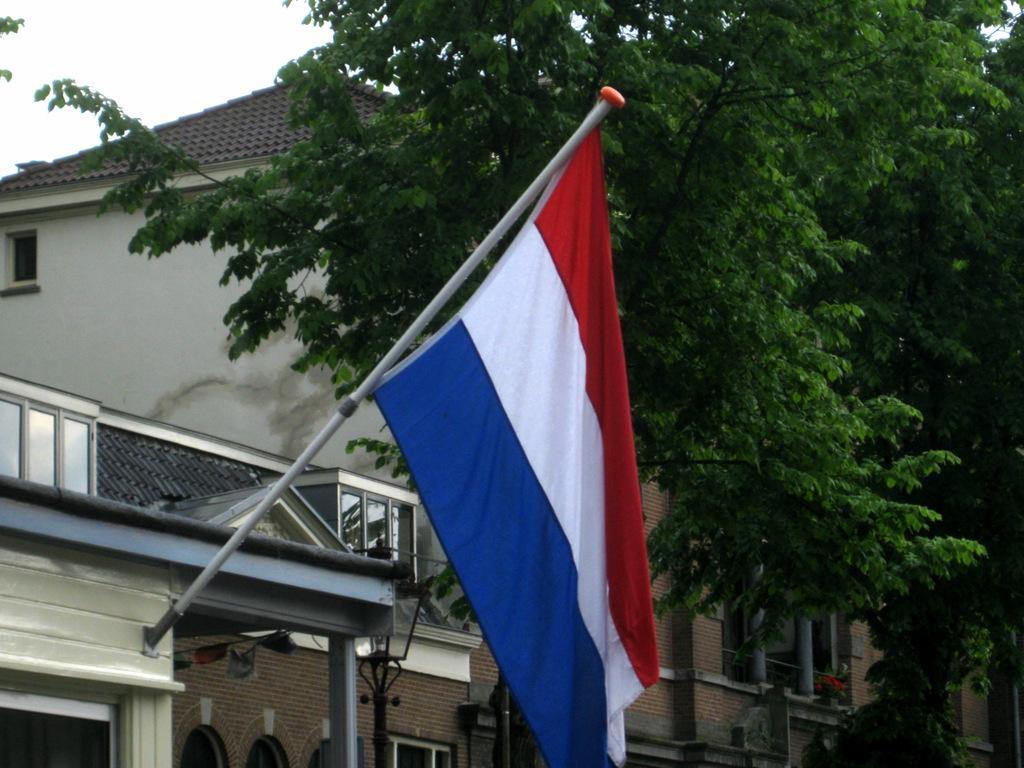In one or two sentences, can you explain what this image depicts? In this image there is a flag hung on top of a house, behind the flag there are trees and buildings. 